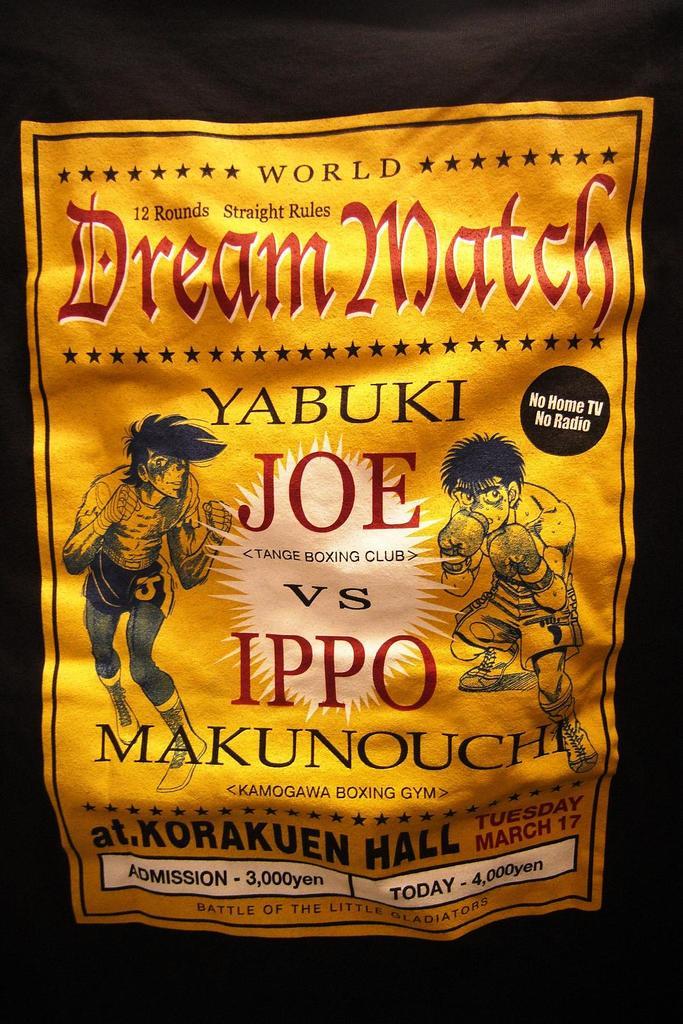Who is yabuki joe fighting?
Give a very brief answer. Ippo makunouchi. How many rounds is this match?
Make the answer very short. 12. 